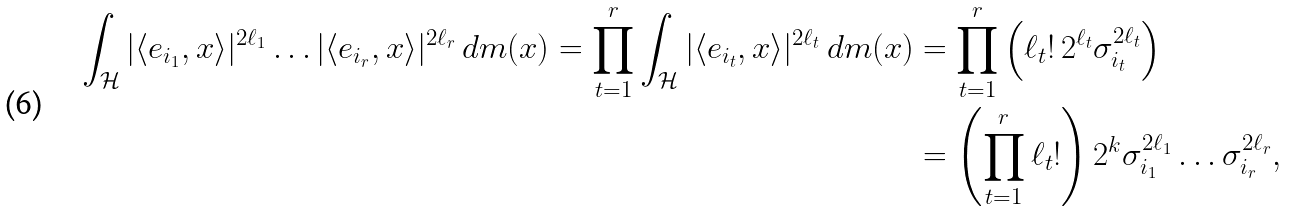<formula> <loc_0><loc_0><loc_500><loc_500>\int _ { \mathcal { H } } | \langle e _ { i _ { 1 } } , x \rangle | ^ { 2 \ell _ { 1 } } \dots | \langle e _ { i _ { r } } , x \rangle | ^ { 2 \ell _ { r } } \, d m ( x ) = \prod _ { t = 1 } ^ { r } \int _ { \mathcal { H } } | \langle e _ { i _ { t } } , x \rangle | ^ { 2 \ell _ { t } } \, d m ( x ) & = \prod _ { t = 1 } ^ { r } \left ( \ell _ { t } ! \, 2 ^ { \ell _ { t } } \sigma _ { i _ { t } } ^ { 2 \ell _ { t } } \right ) \\ & = \left ( \prod _ { t = 1 } ^ { r } \ell _ { t } ! \right ) 2 ^ { k } \sigma _ { i _ { 1 } } ^ { 2 \ell _ { 1 } } \dots \sigma _ { i _ { r } } ^ { 2 \ell _ { r } } ,</formula> 